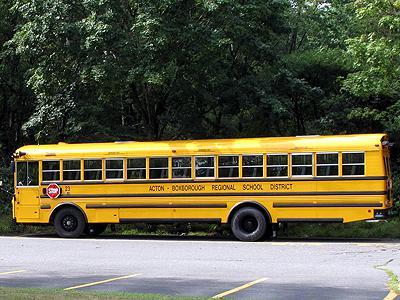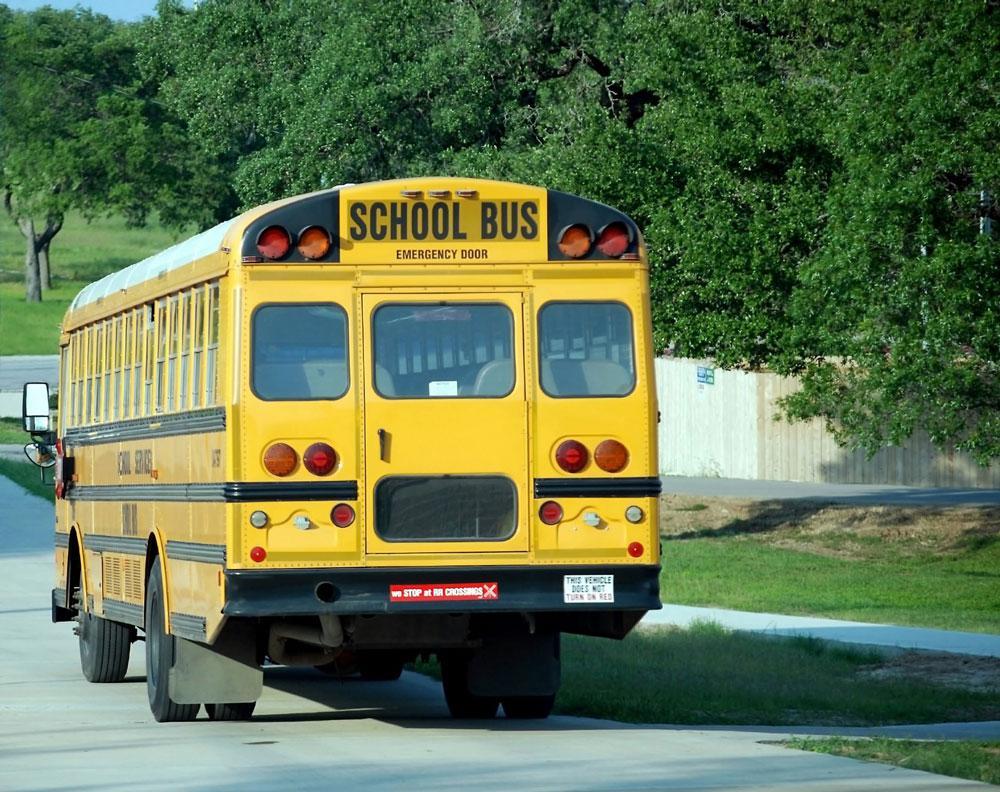The first image is the image on the left, the second image is the image on the right. Considering the images on both sides, is "The entry doors are visible on at least one of the buses." valid? Answer yes or no. No. The first image is the image on the left, the second image is the image on the right. Assess this claim about the two images: "Each image shows a yellow bus with its non-flat front visible, and at least one bus is shown with the passenger entry door visible.". Correct or not? Answer yes or no. No. 